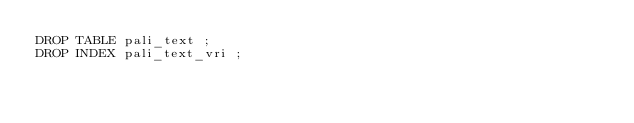Convert code to text. <code><loc_0><loc_0><loc_500><loc_500><_SQL_>DROP TABLE pali_text ;
DROP INDEX pali_text_vri ;</code> 